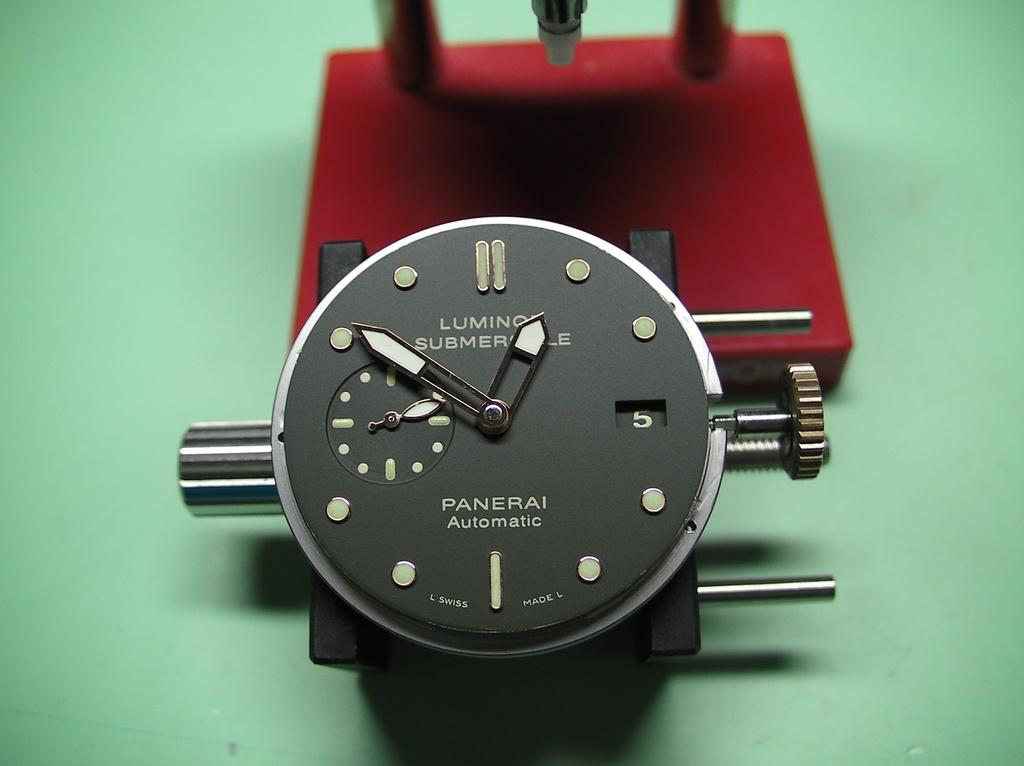<image>
Write a terse but informative summary of the picture. A watch face says Panerai automatic below the hands. 